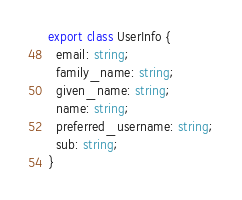Convert code to text. <code><loc_0><loc_0><loc_500><loc_500><_TypeScript_>export class UserInfo {
  email: string;
  family_name: string;
  given_name: string;
  name: string;
  preferred_username: string;
  sub: string;
}</code> 